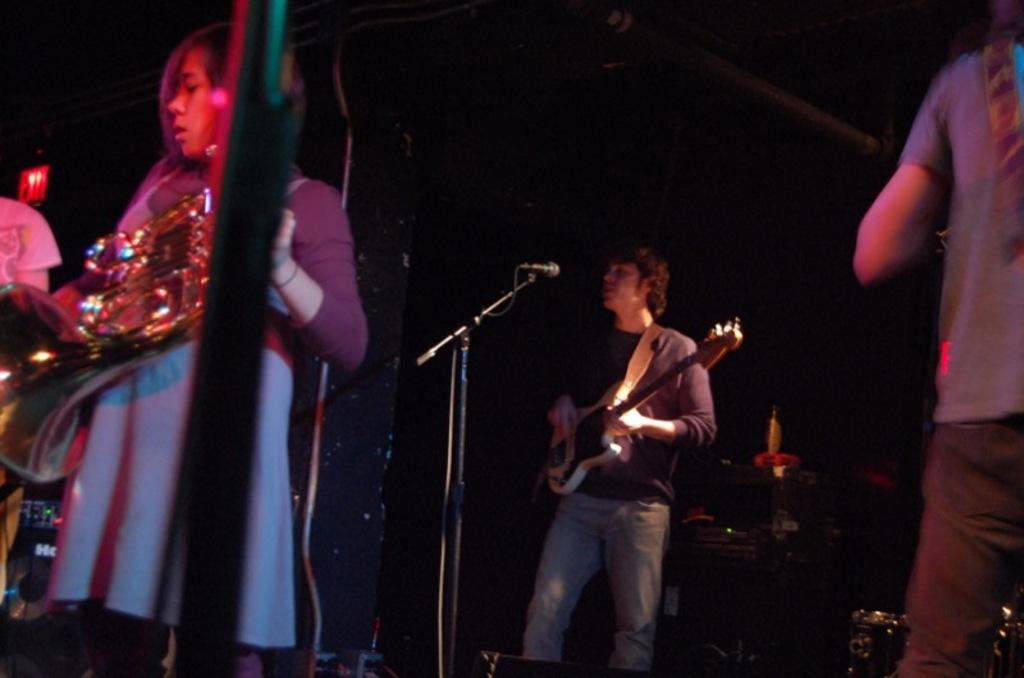What are the people in the image doing? The people in the image are holding guitars. Can you describe the woman in the image? The woman in the image is holding a musical instrument. What type of sack can be seen in the image? There is no sack present in the image. What genre of fiction is being performed in the image? The image does not depict any specific genre of fiction; it shows people holding guitars. 